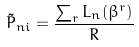<formula> <loc_0><loc_0><loc_500><loc_500>\tilde { P } _ { n i } = \frac { \sum _ { r } L _ { n } ( \beta ^ { r } ) } { R }</formula> 